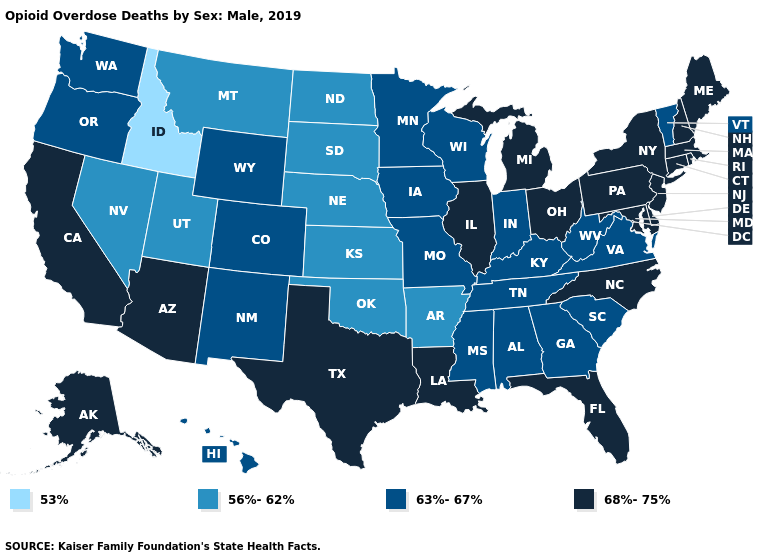Name the states that have a value in the range 63%-67%?
Be succinct. Alabama, Colorado, Georgia, Hawaii, Indiana, Iowa, Kentucky, Minnesota, Mississippi, Missouri, New Mexico, Oregon, South Carolina, Tennessee, Vermont, Virginia, Washington, West Virginia, Wisconsin, Wyoming. What is the value of Louisiana?
Give a very brief answer. 68%-75%. What is the highest value in the Northeast ?
Be succinct. 68%-75%. Name the states that have a value in the range 56%-62%?
Concise answer only. Arkansas, Kansas, Montana, Nebraska, Nevada, North Dakota, Oklahoma, South Dakota, Utah. Name the states that have a value in the range 53%?
Give a very brief answer. Idaho. Name the states that have a value in the range 68%-75%?
Write a very short answer. Alaska, Arizona, California, Connecticut, Delaware, Florida, Illinois, Louisiana, Maine, Maryland, Massachusetts, Michigan, New Hampshire, New Jersey, New York, North Carolina, Ohio, Pennsylvania, Rhode Island, Texas. Does the first symbol in the legend represent the smallest category?
Quick response, please. Yes. What is the highest value in states that border Washington?
Concise answer only. 63%-67%. Does Missouri have the lowest value in the MidWest?
Answer briefly. No. Name the states that have a value in the range 68%-75%?
Be succinct. Alaska, Arizona, California, Connecticut, Delaware, Florida, Illinois, Louisiana, Maine, Maryland, Massachusetts, Michigan, New Hampshire, New Jersey, New York, North Carolina, Ohio, Pennsylvania, Rhode Island, Texas. What is the lowest value in states that border North Dakota?
Quick response, please. 56%-62%. Name the states that have a value in the range 63%-67%?
Be succinct. Alabama, Colorado, Georgia, Hawaii, Indiana, Iowa, Kentucky, Minnesota, Mississippi, Missouri, New Mexico, Oregon, South Carolina, Tennessee, Vermont, Virginia, Washington, West Virginia, Wisconsin, Wyoming. What is the value of Connecticut?
Keep it brief. 68%-75%. Name the states that have a value in the range 53%?
Write a very short answer. Idaho. Does the map have missing data?
Concise answer only. No. 